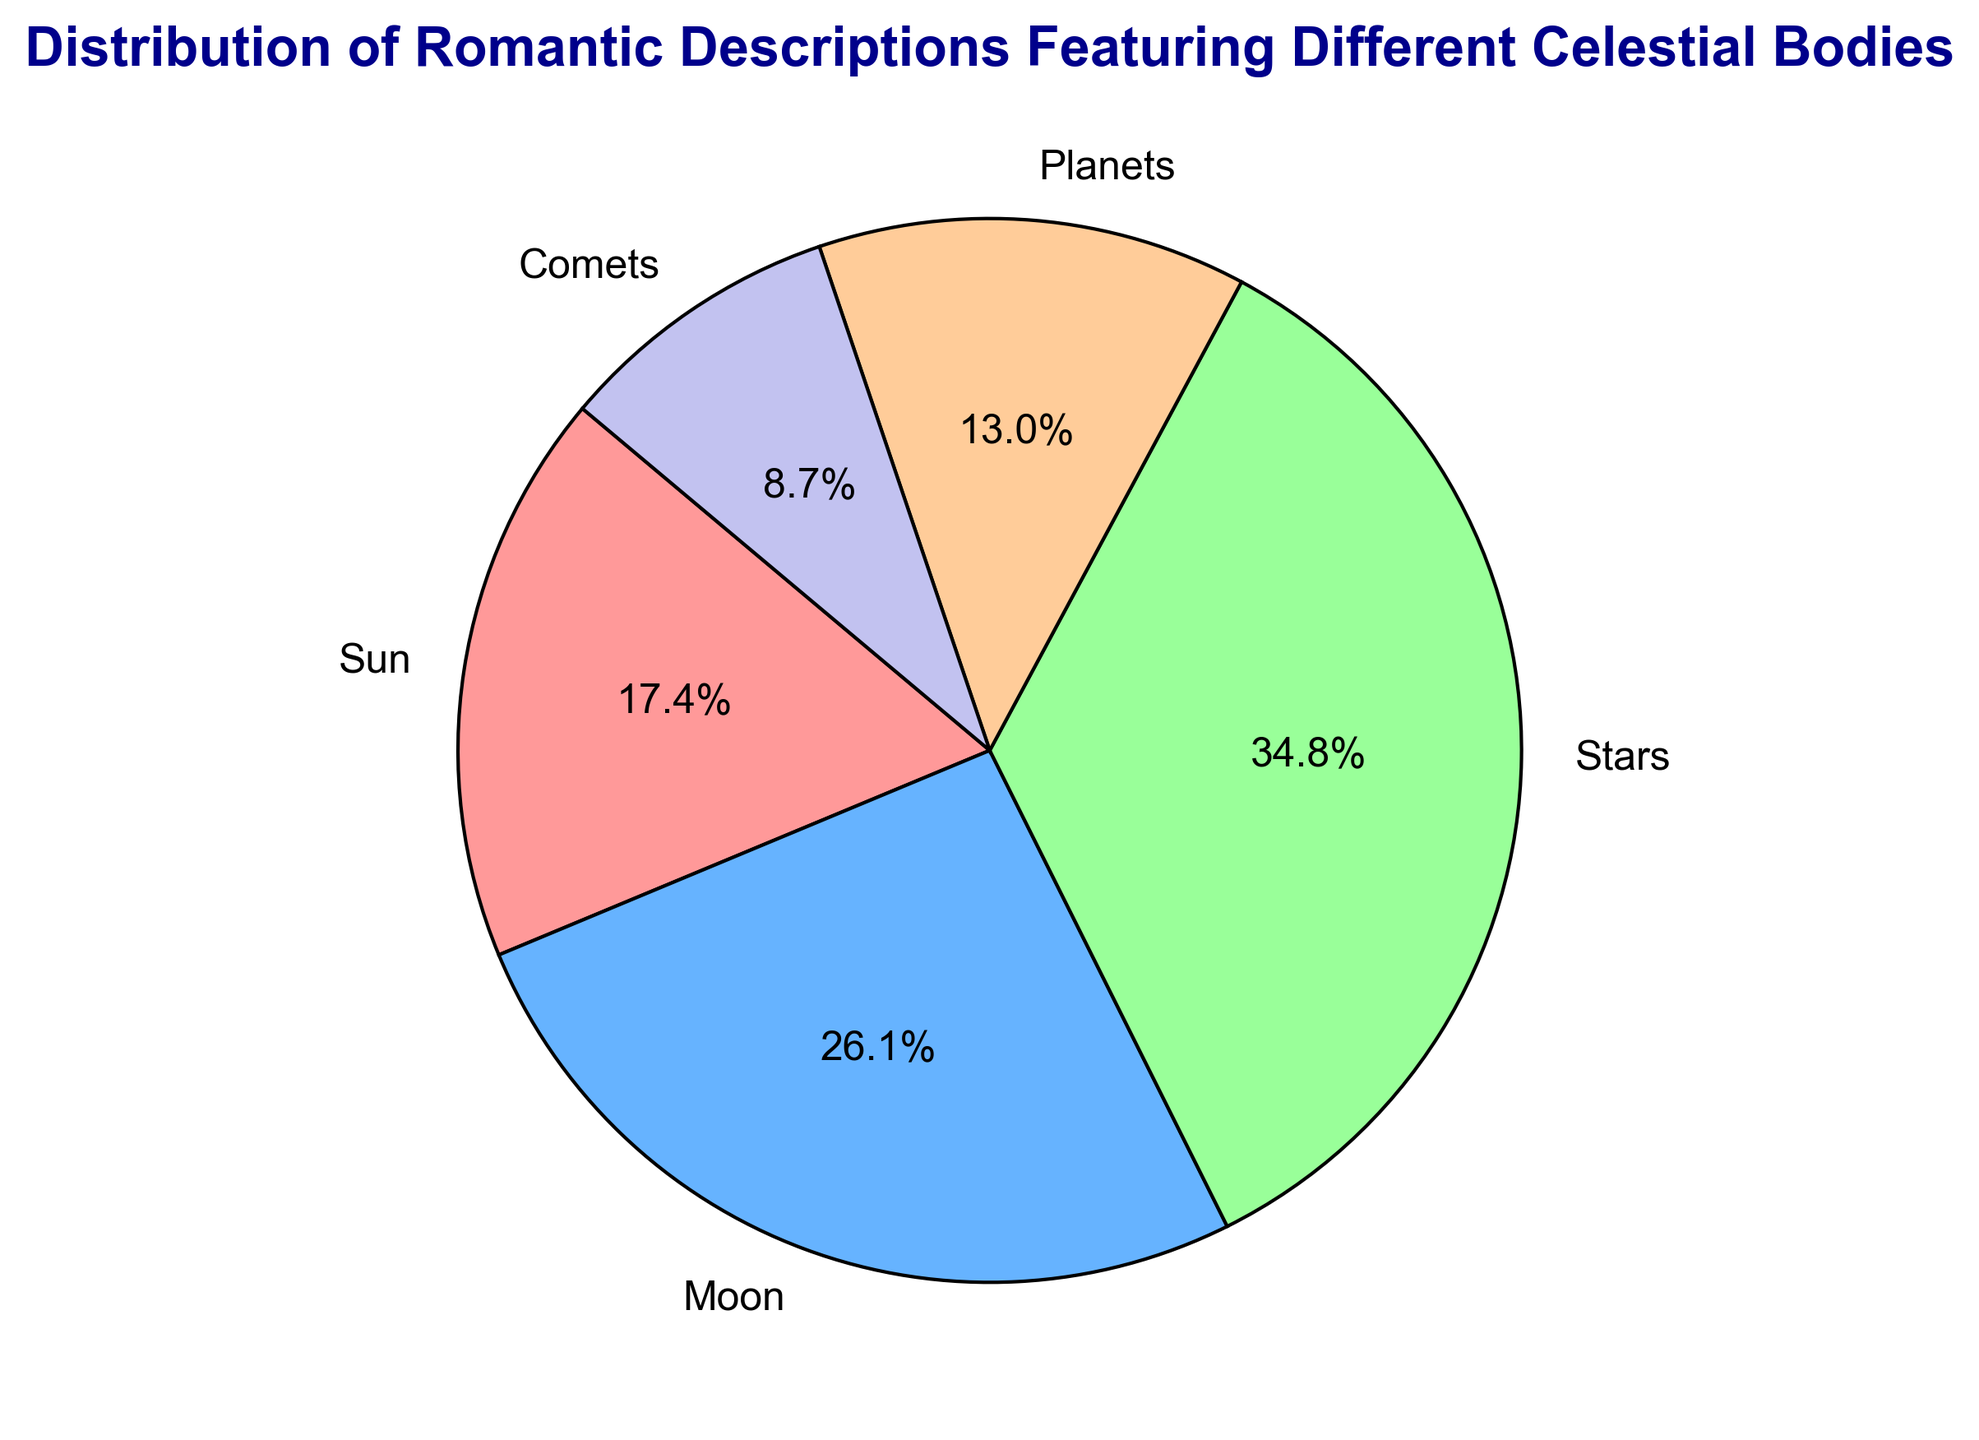What percentage of romantic descriptions feature the Sun? To find the percentage of romantic descriptions that feature the Sun, we look at the slice of the pie chart labeled "Sun" and check the percentage annotation.
Answer: 20% Among the celestial bodies, which one is featured the most in romantic descriptions? By looking at the largest slice of the pie chart, the "Stars" have the highest percentage, making them the most featured celestial body.
Answer: Stars How do the percentages of Moon and Planets compare? We observe the pie chart slices labeled "Moon" and "Planets". The Moon's slice is larger compared to the slice for Planets. The Moon accounts for 30% while the Planets account for 15%.
Answer: Moon 30%, Planets 15% Which celestial body is the least featured? The smallest slice in the pie chart represents the least featured celestial body. The Comets have the smallest slice.
Answer: Comets Calculate the total percentage of descriptions featuring either the Moon or Stars. The Moon's pie chart slice is labeled as 30% and the Stars' slice is labeled as 40%. Summing these two percentages gives 30% + 40% = 70%.
Answer: 70% What is the color of the slice that represents Planets? By examining the color scheme of the pie chart and associating it with the labels, the slice for Planets is represented in a peach-like color.
Answer: Peach-like color How much larger is the percentage for the Stars compared to the Comets? The Stars have a percentage of 40%, and the Comets have a percentage of 10%. Subtracting these values gives 40% - 10% = 30%.
Answer: 30% What is the average percentage of descriptions across all celestial bodies? The total percentage must be 100%. Dividing this evenly among the 5 celestial bodies, we calculate the average as 100% / 5 = 20%.
Answer: 20% Out of the total, what fraction of descriptions features celestial bodies other than the Stars? The Stars account for 40%. Subtracting this from the total gives 100% - 40% = 60%. This 60% represents the other celestial bodies: Sun, Moon, Planets, and Comets.
Answer: 60% 